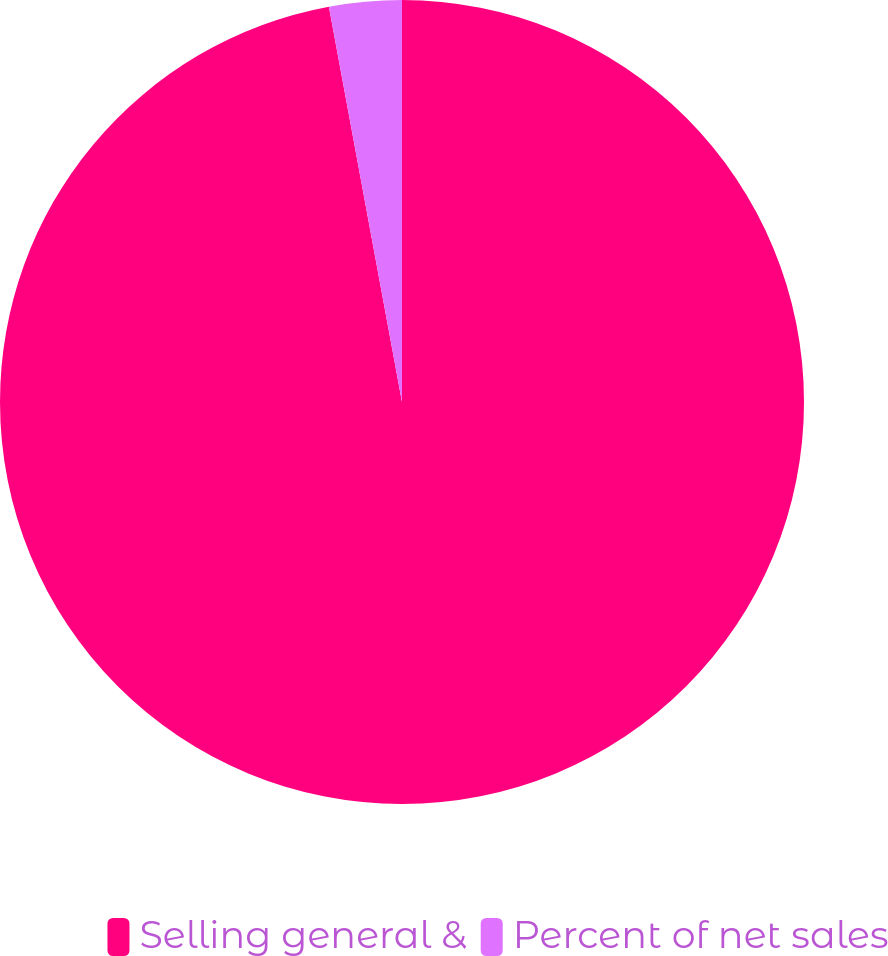Convert chart. <chart><loc_0><loc_0><loc_500><loc_500><pie_chart><fcel>Selling general &<fcel>Percent of net sales<nl><fcel>97.09%<fcel>2.91%<nl></chart> 